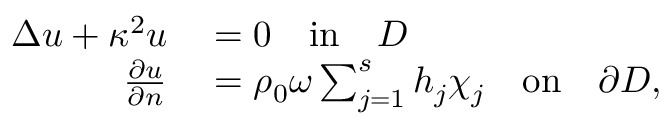Convert formula to latex. <formula><loc_0><loc_0><loc_500><loc_500>\begin{array} { r l } { \Delta u + \kappa ^ { 2 } u } & = 0 \quad i n \quad D } \\ { \frac { \partial u } { \partial n } } & = \rho _ { 0 } \omega \sum _ { j = 1 } ^ { s } h _ { j } \chi _ { j } \quad o n \quad \partial D , } \end{array}</formula> 